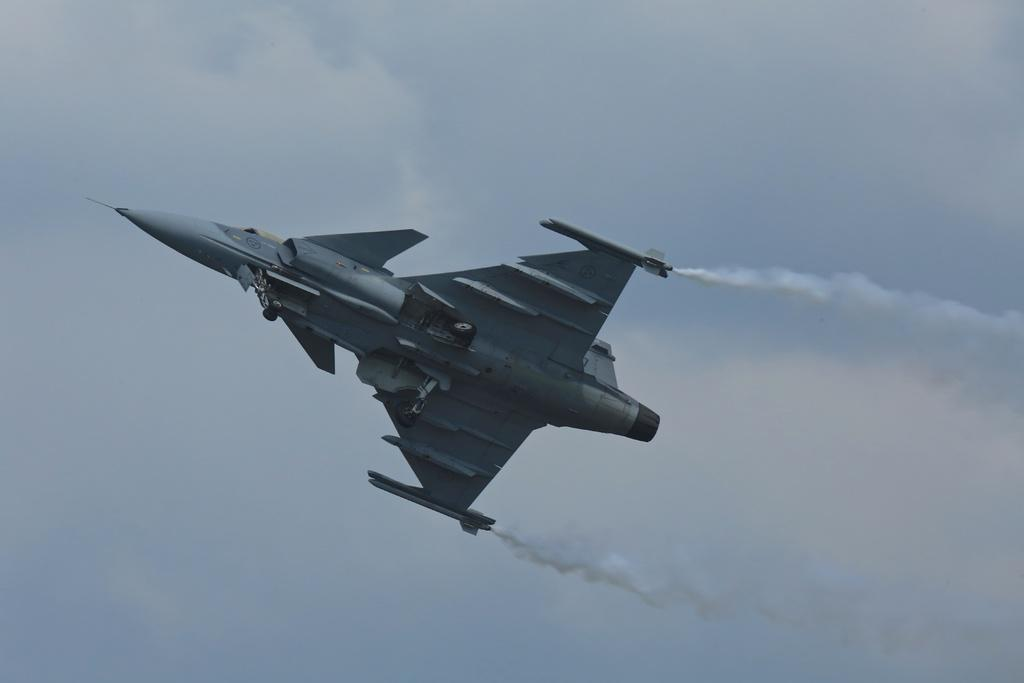What type of aircraft is in the image? There is a fighter jet plane in the image. Where is the fighter jet plane located? The fighter jet plane is in the sky. What type of railway is visible in the image? There is no railway present in the image; it features a fighter jet plane in the sky. How many bees can be seen flying around the fighter jet plane in the image? There are no bees present in the image; it features a fighter jet plane in the sky. 